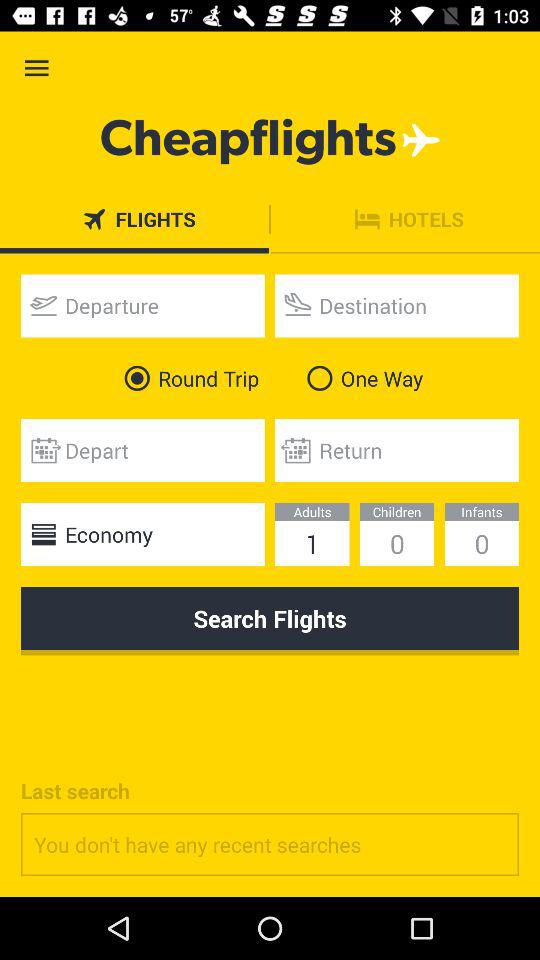What option has been chosen? The option is "Round Trip". 